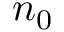<formula> <loc_0><loc_0><loc_500><loc_500>n _ { 0 }</formula> 